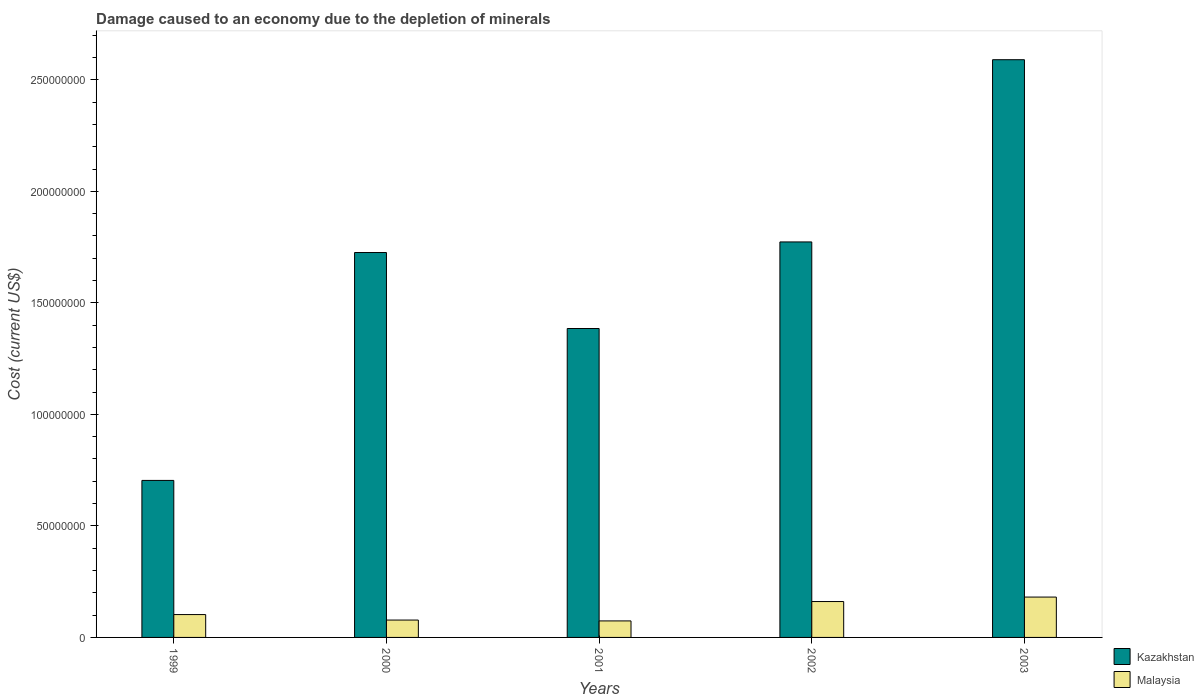How many different coloured bars are there?
Your answer should be very brief. 2. How many groups of bars are there?
Your answer should be compact. 5. Are the number of bars on each tick of the X-axis equal?
Offer a very short reply. Yes. In how many cases, is the number of bars for a given year not equal to the number of legend labels?
Offer a very short reply. 0. What is the cost of damage caused due to the depletion of minerals in Malaysia in 2001?
Provide a short and direct response. 7.40e+06. Across all years, what is the maximum cost of damage caused due to the depletion of minerals in Malaysia?
Offer a very short reply. 1.81e+07. Across all years, what is the minimum cost of damage caused due to the depletion of minerals in Kazakhstan?
Provide a short and direct response. 7.04e+07. In which year was the cost of damage caused due to the depletion of minerals in Kazakhstan maximum?
Your answer should be compact. 2003. In which year was the cost of damage caused due to the depletion of minerals in Malaysia minimum?
Make the answer very short. 2001. What is the total cost of damage caused due to the depletion of minerals in Kazakhstan in the graph?
Your answer should be very brief. 8.18e+08. What is the difference between the cost of damage caused due to the depletion of minerals in Malaysia in 2000 and that in 2002?
Offer a very short reply. -8.30e+06. What is the difference between the cost of damage caused due to the depletion of minerals in Malaysia in 2000 and the cost of damage caused due to the depletion of minerals in Kazakhstan in 2002?
Your answer should be compact. -1.70e+08. What is the average cost of damage caused due to the depletion of minerals in Malaysia per year?
Ensure brevity in your answer.  1.19e+07. In the year 2001, what is the difference between the cost of damage caused due to the depletion of minerals in Kazakhstan and cost of damage caused due to the depletion of minerals in Malaysia?
Your answer should be compact. 1.31e+08. What is the ratio of the cost of damage caused due to the depletion of minerals in Malaysia in 2001 to that in 2003?
Your response must be concise. 0.41. Is the cost of damage caused due to the depletion of minerals in Malaysia in 2001 less than that in 2003?
Offer a very short reply. Yes. What is the difference between the highest and the second highest cost of damage caused due to the depletion of minerals in Kazakhstan?
Offer a terse response. 8.17e+07. What is the difference between the highest and the lowest cost of damage caused due to the depletion of minerals in Malaysia?
Provide a short and direct response. 1.07e+07. Is the sum of the cost of damage caused due to the depletion of minerals in Kazakhstan in 1999 and 2001 greater than the maximum cost of damage caused due to the depletion of minerals in Malaysia across all years?
Ensure brevity in your answer.  Yes. What does the 1st bar from the left in 1999 represents?
Offer a very short reply. Kazakhstan. What does the 2nd bar from the right in 2001 represents?
Make the answer very short. Kazakhstan. How many years are there in the graph?
Offer a terse response. 5. What is the difference between two consecutive major ticks on the Y-axis?
Your answer should be very brief. 5.00e+07. Are the values on the major ticks of Y-axis written in scientific E-notation?
Your answer should be compact. No. Does the graph contain grids?
Your answer should be compact. No. How many legend labels are there?
Your response must be concise. 2. How are the legend labels stacked?
Your response must be concise. Vertical. What is the title of the graph?
Ensure brevity in your answer.  Damage caused to an economy due to the depletion of minerals. What is the label or title of the Y-axis?
Offer a terse response. Cost (current US$). What is the Cost (current US$) of Kazakhstan in 1999?
Ensure brevity in your answer.  7.04e+07. What is the Cost (current US$) in Malaysia in 1999?
Your answer should be very brief. 1.02e+07. What is the Cost (current US$) of Kazakhstan in 2000?
Offer a very short reply. 1.73e+08. What is the Cost (current US$) in Malaysia in 2000?
Keep it short and to the point. 7.79e+06. What is the Cost (current US$) of Kazakhstan in 2001?
Keep it short and to the point. 1.38e+08. What is the Cost (current US$) of Malaysia in 2001?
Ensure brevity in your answer.  7.40e+06. What is the Cost (current US$) of Kazakhstan in 2002?
Make the answer very short. 1.77e+08. What is the Cost (current US$) in Malaysia in 2002?
Keep it short and to the point. 1.61e+07. What is the Cost (current US$) in Kazakhstan in 2003?
Ensure brevity in your answer.  2.59e+08. What is the Cost (current US$) in Malaysia in 2003?
Provide a succinct answer. 1.81e+07. Across all years, what is the maximum Cost (current US$) of Kazakhstan?
Your answer should be very brief. 2.59e+08. Across all years, what is the maximum Cost (current US$) in Malaysia?
Provide a short and direct response. 1.81e+07. Across all years, what is the minimum Cost (current US$) of Kazakhstan?
Provide a succinct answer. 7.04e+07. Across all years, what is the minimum Cost (current US$) of Malaysia?
Offer a terse response. 7.40e+06. What is the total Cost (current US$) in Kazakhstan in the graph?
Give a very brief answer. 8.18e+08. What is the total Cost (current US$) in Malaysia in the graph?
Your response must be concise. 5.96e+07. What is the difference between the Cost (current US$) in Kazakhstan in 1999 and that in 2000?
Provide a short and direct response. -1.02e+08. What is the difference between the Cost (current US$) in Malaysia in 1999 and that in 2000?
Ensure brevity in your answer.  2.46e+06. What is the difference between the Cost (current US$) of Kazakhstan in 1999 and that in 2001?
Provide a succinct answer. -6.81e+07. What is the difference between the Cost (current US$) of Malaysia in 1999 and that in 2001?
Make the answer very short. 2.85e+06. What is the difference between the Cost (current US$) in Kazakhstan in 1999 and that in 2002?
Your answer should be compact. -1.07e+08. What is the difference between the Cost (current US$) of Malaysia in 1999 and that in 2002?
Give a very brief answer. -5.84e+06. What is the difference between the Cost (current US$) of Kazakhstan in 1999 and that in 2003?
Ensure brevity in your answer.  -1.89e+08. What is the difference between the Cost (current US$) in Malaysia in 1999 and that in 2003?
Offer a very short reply. -7.84e+06. What is the difference between the Cost (current US$) of Kazakhstan in 2000 and that in 2001?
Keep it short and to the point. 3.41e+07. What is the difference between the Cost (current US$) in Malaysia in 2000 and that in 2001?
Ensure brevity in your answer.  3.87e+05. What is the difference between the Cost (current US$) of Kazakhstan in 2000 and that in 2002?
Provide a succinct answer. -4.75e+06. What is the difference between the Cost (current US$) of Malaysia in 2000 and that in 2002?
Make the answer very short. -8.30e+06. What is the difference between the Cost (current US$) of Kazakhstan in 2000 and that in 2003?
Provide a succinct answer. -8.64e+07. What is the difference between the Cost (current US$) of Malaysia in 2000 and that in 2003?
Make the answer very short. -1.03e+07. What is the difference between the Cost (current US$) in Kazakhstan in 2001 and that in 2002?
Offer a terse response. -3.88e+07. What is the difference between the Cost (current US$) of Malaysia in 2001 and that in 2002?
Keep it short and to the point. -8.69e+06. What is the difference between the Cost (current US$) in Kazakhstan in 2001 and that in 2003?
Your answer should be compact. -1.21e+08. What is the difference between the Cost (current US$) in Malaysia in 2001 and that in 2003?
Ensure brevity in your answer.  -1.07e+07. What is the difference between the Cost (current US$) of Kazakhstan in 2002 and that in 2003?
Your answer should be very brief. -8.17e+07. What is the difference between the Cost (current US$) of Malaysia in 2002 and that in 2003?
Ensure brevity in your answer.  -2.00e+06. What is the difference between the Cost (current US$) of Kazakhstan in 1999 and the Cost (current US$) of Malaysia in 2000?
Make the answer very short. 6.26e+07. What is the difference between the Cost (current US$) of Kazakhstan in 1999 and the Cost (current US$) of Malaysia in 2001?
Keep it short and to the point. 6.30e+07. What is the difference between the Cost (current US$) of Kazakhstan in 1999 and the Cost (current US$) of Malaysia in 2002?
Provide a short and direct response. 5.43e+07. What is the difference between the Cost (current US$) of Kazakhstan in 1999 and the Cost (current US$) of Malaysia in 2003?
Keep it short and to the point. 5.23e+07. What is the difference between the Cost (current US$) of Kazakhstan in 2000 and the Cost (current US$) of Malaysia in 2001?
Your answer should be compact. 1.65e+08. What is the difference between the Cost (current US$) of Kazakhstan in 2000 and the Cost (current US$) of Malaysia in 2002?
Your answer should be very brief. 1.56e+08. What is the difference between the Cost (current US$) of Kazakhstan in 2000 and the Cost (current US$) of Malaysia in 2003?
Provide a short and direct response. 1.54e+08. What is the difference between the Cost (current US$) in Kazakhstan in 2001 and the Cost (current US$) in Malaysia in 2002?
Keep it short and to the point. 1.22e+08. What is the difference between the Cost (current US$) of Kazakhstan in 2001 and the Cost (current US$) of Malaysia in 2003?
Give a very brief answer. 1.20e+08. What is the difference between the Cost (current US$) of Kazakhstan in 2002 and the Cost (current US$) of Malaysia in 2003?
Provide a short and direct response. 1.59e+08. What is the average Cost (current US$) in Kazakhstan per year?
Your response must be concise. 1.64e+08. What is the average Cost (current US$) in Malaysia per year?
Your answer should be compact. 1.19e+07. In the year 1999, what is the difference between the Cost (current US$) of Kazakhstan and Cost (current US$) of Malaysia?
Make the answer very short. 6.01e+07. In the year 2000, what is the difference between the Cost (current US$) in Kazakhstan and Cost (current US$) in Malaysia?
Offer a very short reply. 1.65e+08. In the year 2001, what is the difference between the Cost (current US$) in Kazakhstan and Cost (current US$) in Malaysia?
Your answer should be compact. 1.31e+08. In the year 2002, what is the difference between the Cost (current US$) in Kazakhstan and Cost (current US$) in Malaysia?
Provide a succinct answer. 1.61e+08. In the year 2003, what is the difference between the Cost (current US$) in Kazakhstan and Cost (current US$) in Malaysia?
Keep it short and to the point. 2.41e+08. What is the ratio of the Cost (current US$) of Kazakhstan in 1999 to that in 2000?
Provide a short and direct response. 0.41. What is the ratio of the Cost (current US$) in Malaysia in 1999 to that in 2000?
Your answer should be compact. 1.32. What is the ratio of the Cost (current US$) of Kazakhstan in 1999 to that in 2001?
Your answer should be compact. 0.51. What is the ratio of the Cost (current US$) in Malaysia in 1999 to that in 2001?
Your answer should be very brief. 1.38. What is the ratio of the Cost (current US$) of Kazakhstan in 1999 to that in 2002?
Provide a succinct answer. 0.4. What is the ratio of the Cost (current US$) in Malaysia in 1999 to that in 2002?
Give a very brief answer. 0.64. What is the ratio of the Cost (current US$) in Kazakhstan in 1999 to that in 2003?
Make the answer very short. 0.27. What is the ratio of the Cost (current US$) of Malaysia in 1999 to that in 2003?
Your response must be concise. 0.57. What is the ratio of the Cost (current US$) in Kazakhstan in 2000 to that in 2001?
Provide a short and direct response. 1.25. What is the ratio of the Cost (current US$) of Malaysia in 2000 to that in 2001?
Your response must be concise. 1.05. What is the ratio of the Cost (current US$) in Kazakhstan in 2000 to that in 2002?
Give a very brief answer. 0.97. What is the ratio of the Cost (current US$) of Malaysia in 2000 to that in 2002?
Keep it short and to the point. 0.48. What is the ratio of the Cost (current US$) in Kazakhstan in 2000 to that in 2003?
Offer a very short reply. 0.67. What is the ratio of the Cost (current US$) in Malaysia in 2000 to that in 2003?
Your answer should be compact. 0.43. What is the ratio of the Cost (current US$) of Kazakhstan in 2001 to that in 2002?
Give a very brief answer. 0.78. What is the ratio of the Cost (current US$) of Malaysia in 2001 to that in 2002?
Provide a short and direct response. 0.46. What is the ratio of the Cost (current US$) in Kazakhstan in 2001 to that in 2003?
Provide a succinct answer. 0.53. What is the ratio of the Cost (current US$) in Malaysia in 2001 to that in 2003?
Give a very brief answer. 0.41. What is the ratio of the Cost (current US$) of Kazakhstan in 2002 to that in 2003?
Provide a succinct answer. 0.68. What is the ratio of the Cost (current US$) of Malaysia in 2002 to that in 2003?
Offer a terse response. 0.89. What is the difference between the highest and the second highest Cost (current US$) in Kazakhstan?
Offer a very short reply. 8.17e+07. What is the difference between the highest and the second highest Cost (current US$) in Malaysia?
Provide a succinct answer. 2.00e+06. What is the difference between the highest and the lowest Cost (current US$) in Kazakhstan?
Keep it short and to the point. 1.89e+08. What is the difference between the highest and the lowest Cost (current US$) of Malaysia?
Offer a terse response. 1.07e+07. 